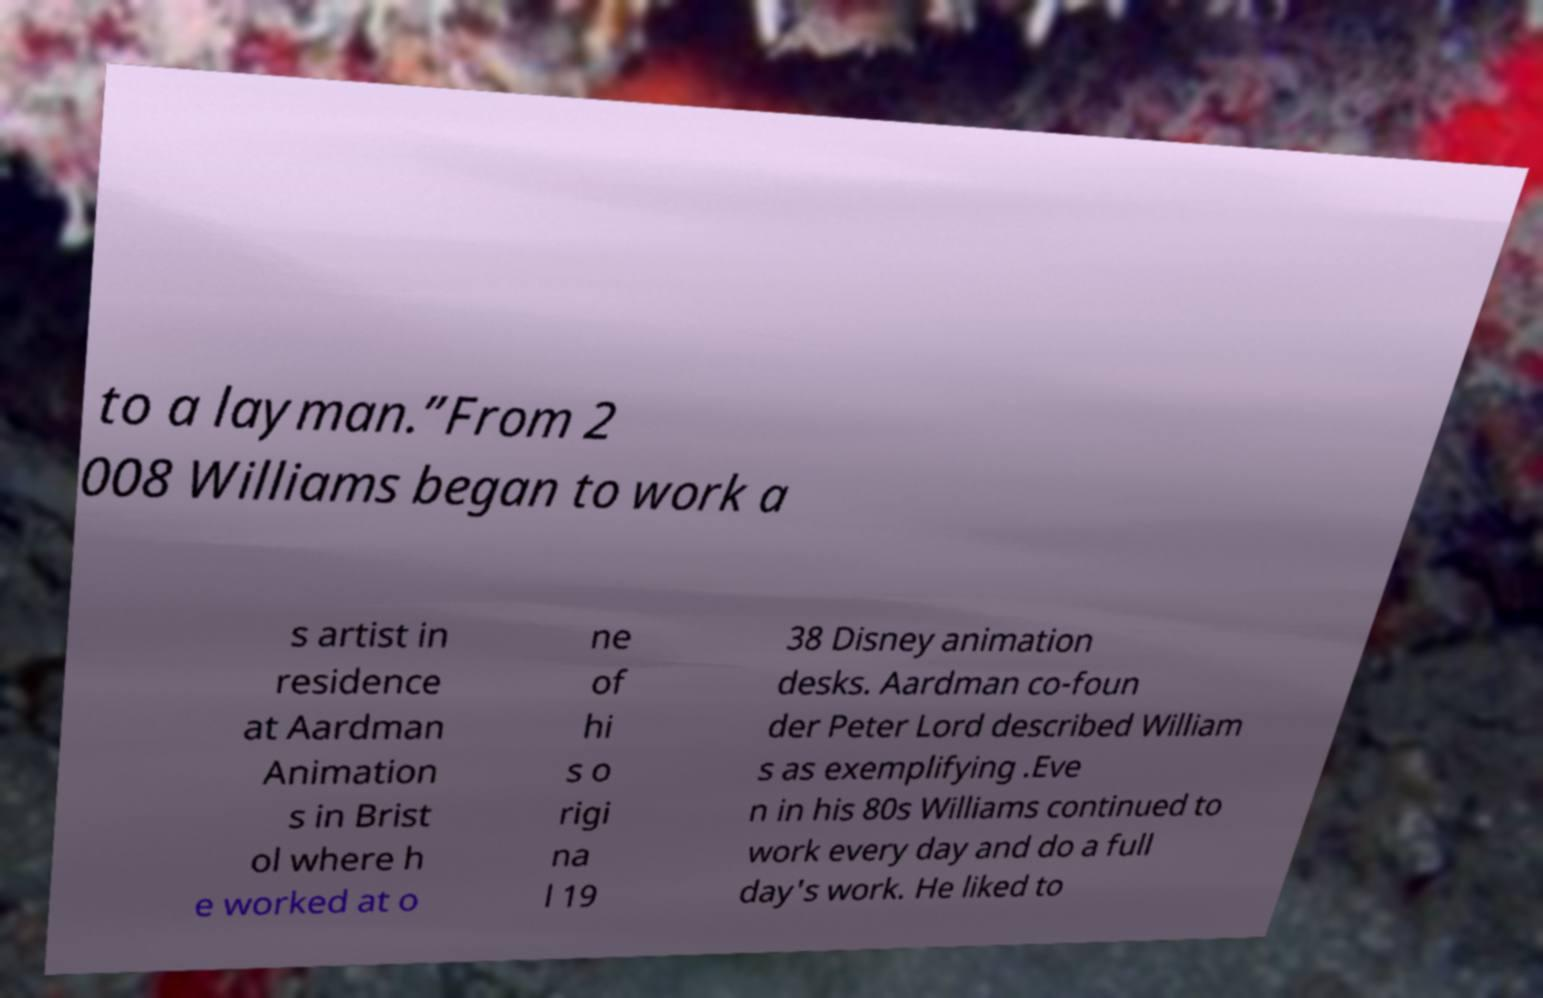What messages or text are displayed in this image? I need them in a readable, typed format. to a layman.”From 2 008 Williams began to work a s artist in residence at Aardman Animation s in Brist ol where h e worked at o ne of hi s o rigi na l 19 38 Disney animation desks. Aardman co-foun der Peter Lord described William s as exemplifying .Eve n in his 80s Williams continued to work every day and do a full day's work. He liked to 